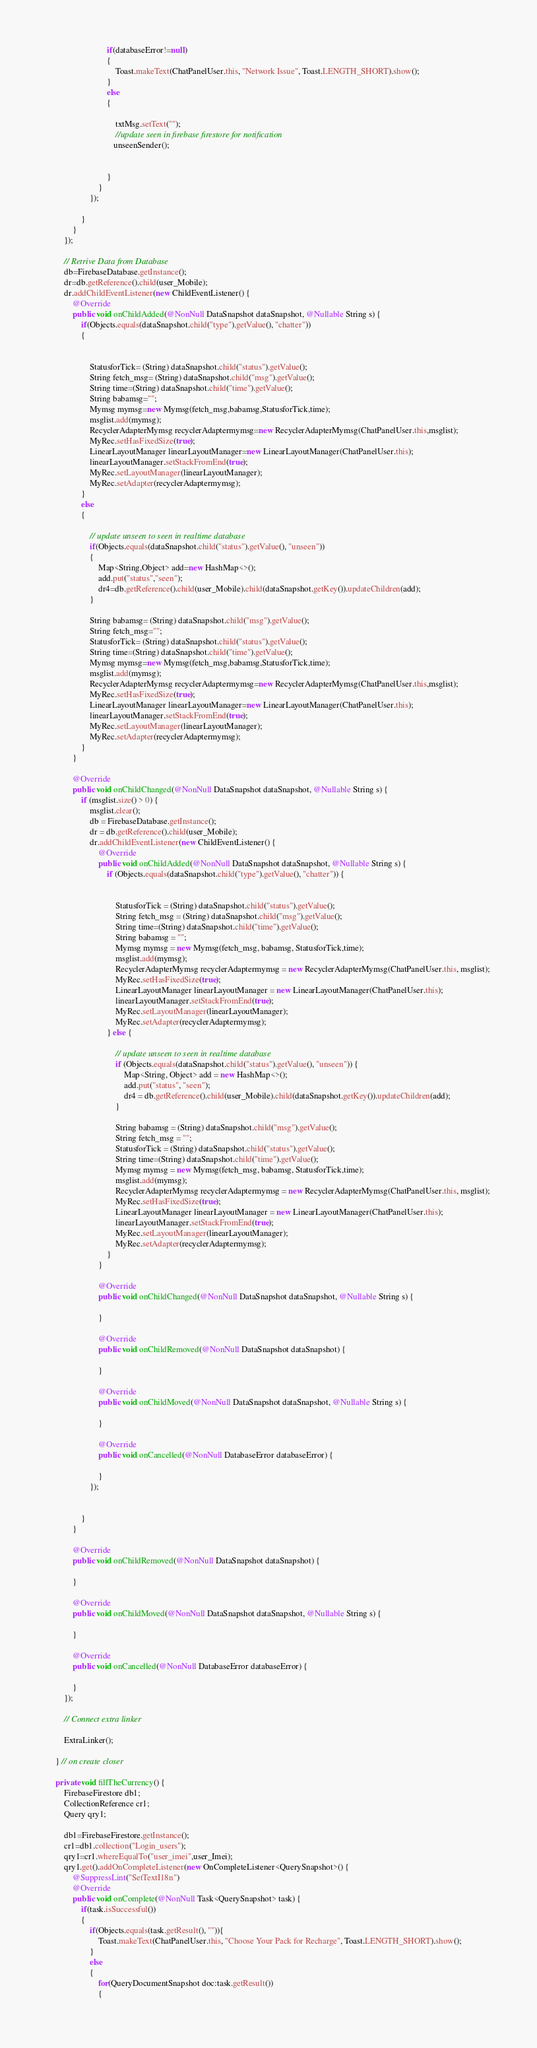<code> <loc_0><loc_0><loc_500><loc_500><_Java_>
                            if(databaseError!=null)
                            {
                                Toast.makeText(ChatPanelUser.this, "Network Issue", Toast.LENGTH_SHORT).show();
                            }
                            else
                            {

                                txtMsg.setText("");
                                //update seen in firebase firestore for notification
                               unseenSender();


                            }
                        }
                    });

                }
            }
        });

        // Retrive Data from Database
        db=FirebaseDatabase.getInstance();
        dr=db.getReference().child(user_Mobile);
        dr.addChildEventListener(new ChildEventListener() {
            @Override
            public void onChildAdded(@NonNull DataSnapshot dataSnapshot, @Nullable String s) {
                if(Objects.equals(dataSnapshot.child("type").getValue(), "chatter"))
                {


                    StatusforTick= (String) dataSnapshot.child("status").getValue();
                    String fetch_msg= (String) dataSnapshot.child("msg").getValue();
                    String time=(String) dataSnapshot.child("time").getValue();
                    String babamsg="";
                    Mymsg mymsg=new Mymsg(fetch_msg,babamsg,StatusforTick,time);
                    msglist.add(mymsg);
                    RecyclerAdapterMymsg recyclerAdaptermymsg=new RecyclerAdapterMymsg(ChatPanelUser.this,msglist);
                    MyRec.setHasFixedSize(true);
                    LinearLayoutManager linearLayoutManager=new LinearLayoutManager(ChatPanelUser.this);
                    linearLayoutManager.setStackFromEnd(true);
                    MyRec.setLayoutManager(linearLayoutManager);
                    MyRec.setAdapter(recyclerAdaptermymsg);
                }
                else
                {

                    // update unseen to seen in realtime database
                    if(Objects.equals(dataSnapshot.child("status").getValue(), "unseen"))
                    {
                        Map<String,Object> add=new HashMap<>();
                        add.put("status","seen");
                        dr4=db.getReference().child(user_Mobile).child(dataSnapshot.getKey()).updateChildren(add);
                    }

                    String babamsg= (String) dataSnapshot.child("msg").getValue();
                    String fetch_msg="";
                    StatusforTick= (String) dataSnapshot.child("status").getValue();
                    String time=(String) dataSnapshot.child("time").getValue();
                    Mymsg mymsg=new Mymsg(fetch_msg,babamsg,StatusforTick,time);
                    msglist.add(mymsg);
                    RecyclerAdapterMymsg recyclerAdaptermymsg=new RecyclerAdapterMymsg(ChatPanelUser.this,msglist);
                    MyRec.setHasFixedSize(true);
                    LinearLayoutManager linearLayoutManager=new LinearLayoutManager(ChatPanelUser.this);
                    linearLayoutManager.setStackFromEnd(true);
                    MyRec.setLayoutManager(linearLayoutManager);
                    MyRec.setAdapter(recyclerAdaptermymsg);
                }
            }

            @Override
            public void onChildChanged(@NonNull DataSnapshot dataSnapshot, @Nullable String s) {
                if (msglist.size() > 0) {
                    msglist.clear();
                    db = FirebaseDatabase.getInstance();
                    dr = db.getReference().child(user_Mobile);
                    dr.addChildEventListener(new ChildEventListener() {
                        @Override
                        public void onChildAdded(@NonNull DataSnapshot dataSnapshot, @Nullable String s) {
                            if (Objects.equals(dataSnapshot.child("type").getValue(), "chatter")) {


                                StatusforTick = (String) dataSnapshot.child("status").getValue();
                                String fetch_msg = (String) dataSnapshot.child("msg").getValue();
                                String time=(String) dataSnapshot.child("time").getValue();
                                String babamsg = "";
                                Mymsg mymsg = new Mymsg(fetch_msg, babamsg, StatusforTick,time);
                                msglist.add(mymsg);
                                RecyclerAdapterMymsg recyclerAdaptermymsg = new RecyclerAdapterMymsg(ChatPanelUser.this, msglist);
                                MyRec.setHasFixedSize(true);
                                LinearLayoutManager linearLayoutManager = new LinearLayoutManager(ChatPanelUser.this);
                                linearLayoutManager.setStackFromEnd(true);
                                MyRec.setLayoutManager(linearLayoutManager);
                                MyRec.setAdapter(recyclerAdaptermymsg);
                            } else {

                                // update unseen to seen in realtime database
                                if (Objects.equals(dataSnapshot.child("status").getValue(), "unseen")) {
                                    Map<String, Object> add = new HashMap<>();
                                    add.put("status", "seen");
                                    dr4 = db.getReference().child(user_Mobile).child(dataSnapshot.getKey()).updateChildren(add);
                                }

                                String babamsg = (String) dataSnapshot.child("msg").getValue();
                                String fetch_msg = "";
                                StatusforTick = (String) dataSnapshot.child("status").getValue();
                                String time=(String) dataSnapshot.child("time").getValue();
                                Mymsg mymsg = new Mymsg(fetch_msg, babamsg, StatusforTick,time);
                                msglist.add(mymsg);
                                RecyclerAdapterMymsg recyclerAdaptermymsg = new RecyclerAdapterMymsg(ChatPanelUser.this, msglist);
                                MyRec.setHasFixedSize(true);
                                LinearLayoutManager linearLayoutManager = new LinearLayoutManager(ChatPanelUser.this);
                                linearLayoutManager.setStackFromEnd(true);
                                MyRec.setLayoutManager(linearLayoutManager);
                                MyRec.setAdapter(recyclerAdaptermymsg);
                            }
                        }

                        @Override
                        public void onChildChanged(@NonNull DataSnapshot dataSnapshot, @Nullable String s) {

                        }

                        @Override
                        public void onChildRemoved(@NonNull DataSnapshot dataSnapshot) {

                        }

                        @Override
                        public void onChildMoved(@NonNull DataSnapshot dataSnapshot, @Nullable String s) {

                        }

                        @Override
                        public void onCancelled(@NonNull DatabaseError databaseError) {

                        }
                    });


                }
            }

            @Override
            public void onChildRemoved(@NonNull DataSnapshot dataSnapshot) {

            }

            @Override
            public void onChildMoved(@NonNull DataSnapshot dataSnapshot, @Nullable String s) {

            }

            @Override
            public void onCancelled(@NonNull DatabaseError databaseError) {

            }
        });

        // Connect extra linker

        ExtraLinker();

    } // on create closer

    private void fillTheCurrency() {
        FirebaseFirestore db1;
        CollectionReference cr1;
        Query qry1;

        db1=FirebaseFirestore.getInstance();
        cr1=db1.collection("Login_users");
        qry1=cr1.whereEqualTo("user_imei",user_Imei);
        qry1.get().addOnCompleteListener(new OnCompleteListener<QuerySnapshot>() {
            @SuppressLint("SetTextI18n")
            @Override
            public void onComplete(@NonNull Task<QuerySnapshot> task) {
                if(task.isSuccessful())
                {
                    if(Objects.equals(task.getResult(), "")){
                        Toast.makeText(ChatPanelUser.this, "Choose Your Pack for Recharge", Toast.LENGTH_SHORT).show();
                    }
                    else
                    {
                        for(QueryDocumentSnapshot doc:task.getResult())
                        {</code> 